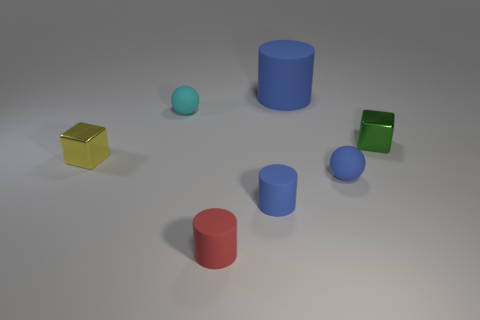There is a red cylinder that is the same material as the cyan thing; what size is it?
Ensure brevity in your answer.  Small. Is the size of the blue ball to the right of the cyan matte sphere the same as the large blue rubber object?
Provide a succinct answer. No. What is the shape of the metal object that is to the right of the matte sphere right of the tiny matte object that is behind the small yellow cube?
Offer a terse response. Cube. How many objects are green objects or blue balls that are in front of the green block?
Provide a succinct answer. 2. There is a block that is left of the green object; what size is it?
Provide a short and direct response. Small. Does the small green cube have the same material as the small cube to the left of the big blue cylinder?
Provide a short and direct response. Yes. There is a rubber ball on the right side of the cylinder that is behind the blue rubber sphere; what number of blue spheres are behind it?
Offer a very short reply. 0. How many blue objects are either large objects or tiny shiny blocks?
Your answer should be very brief. 1. What shape is the large blue rubber thing behind the tiny blue matte cylinder?
Make the answer very short. Cylinder. There is another matte ball that is the same size as the cyan matte ball; what is its color?
Provide a short and direct response. Blue. 